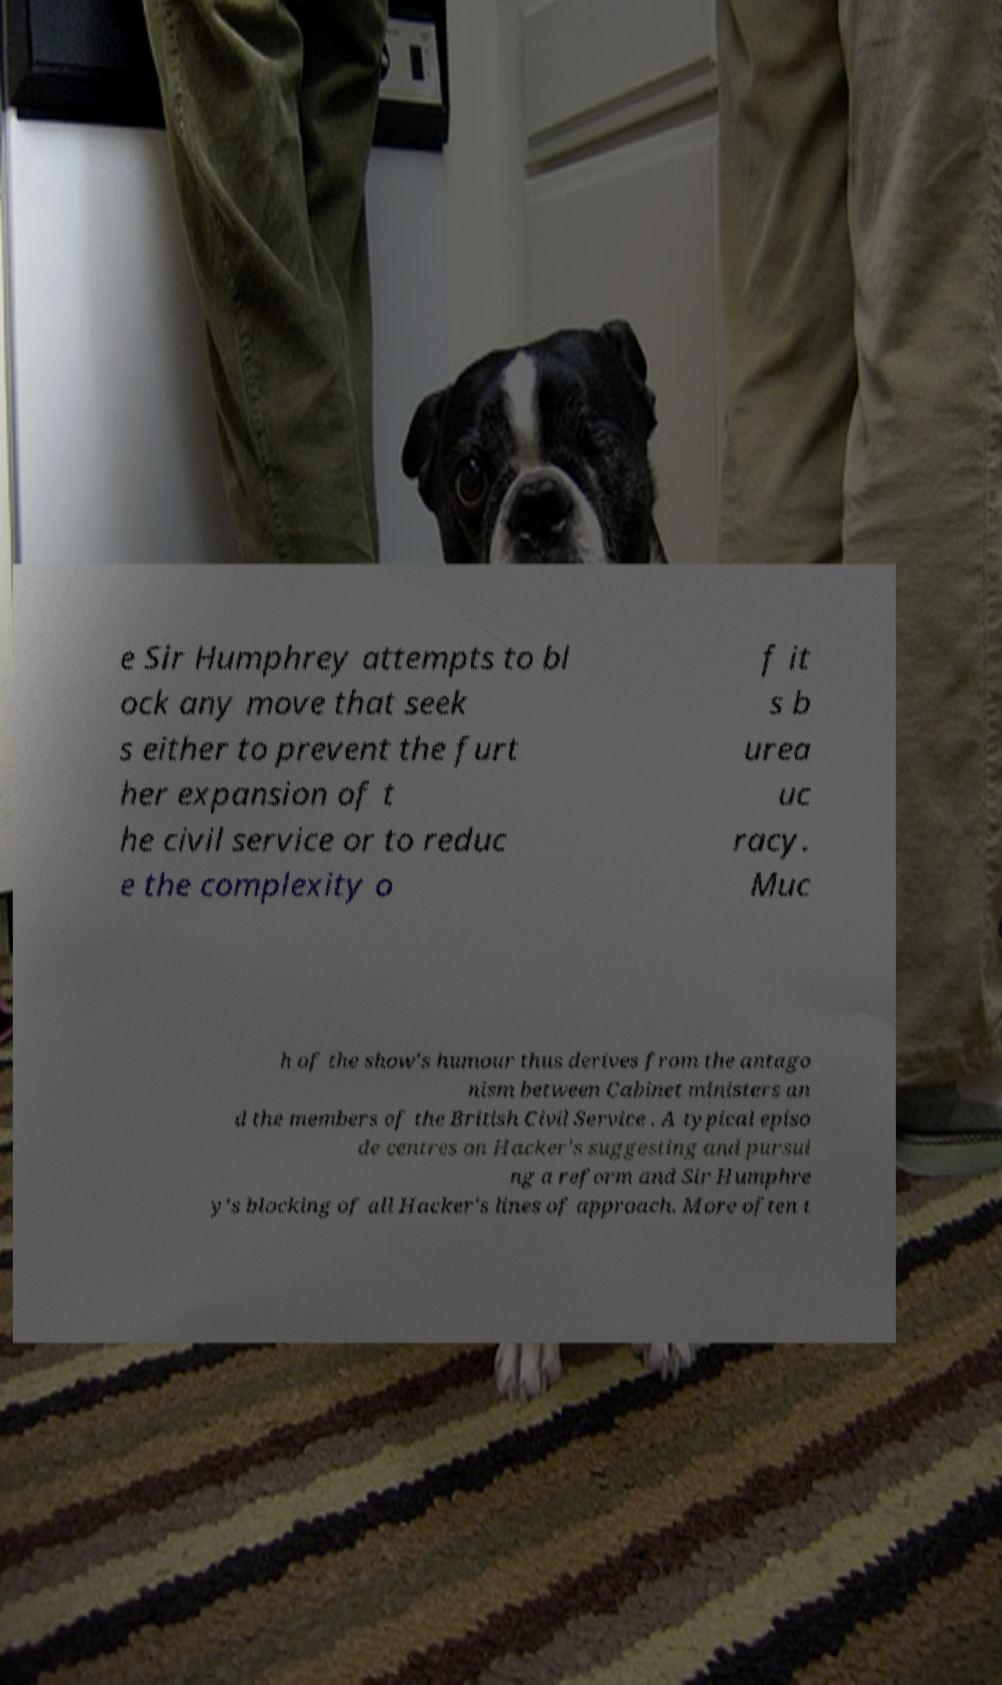I need the written content from this picture converted into text. Can you do that? e Sir Humphrey attempts to bl ock any move that seek s either to prevent the furt her expansion of t he civil service or to reduc e the complexity o f it s b urea uc racy. Muc h of the show's humour thus derives from the antago nism between Cabinet ministers an d the members of the British Civil Service . A typical episo de centres on Hacker's suggesting and pursui ng a reform and Sir Humphre y's blocking of all Hacker's lines of approach. More often t 